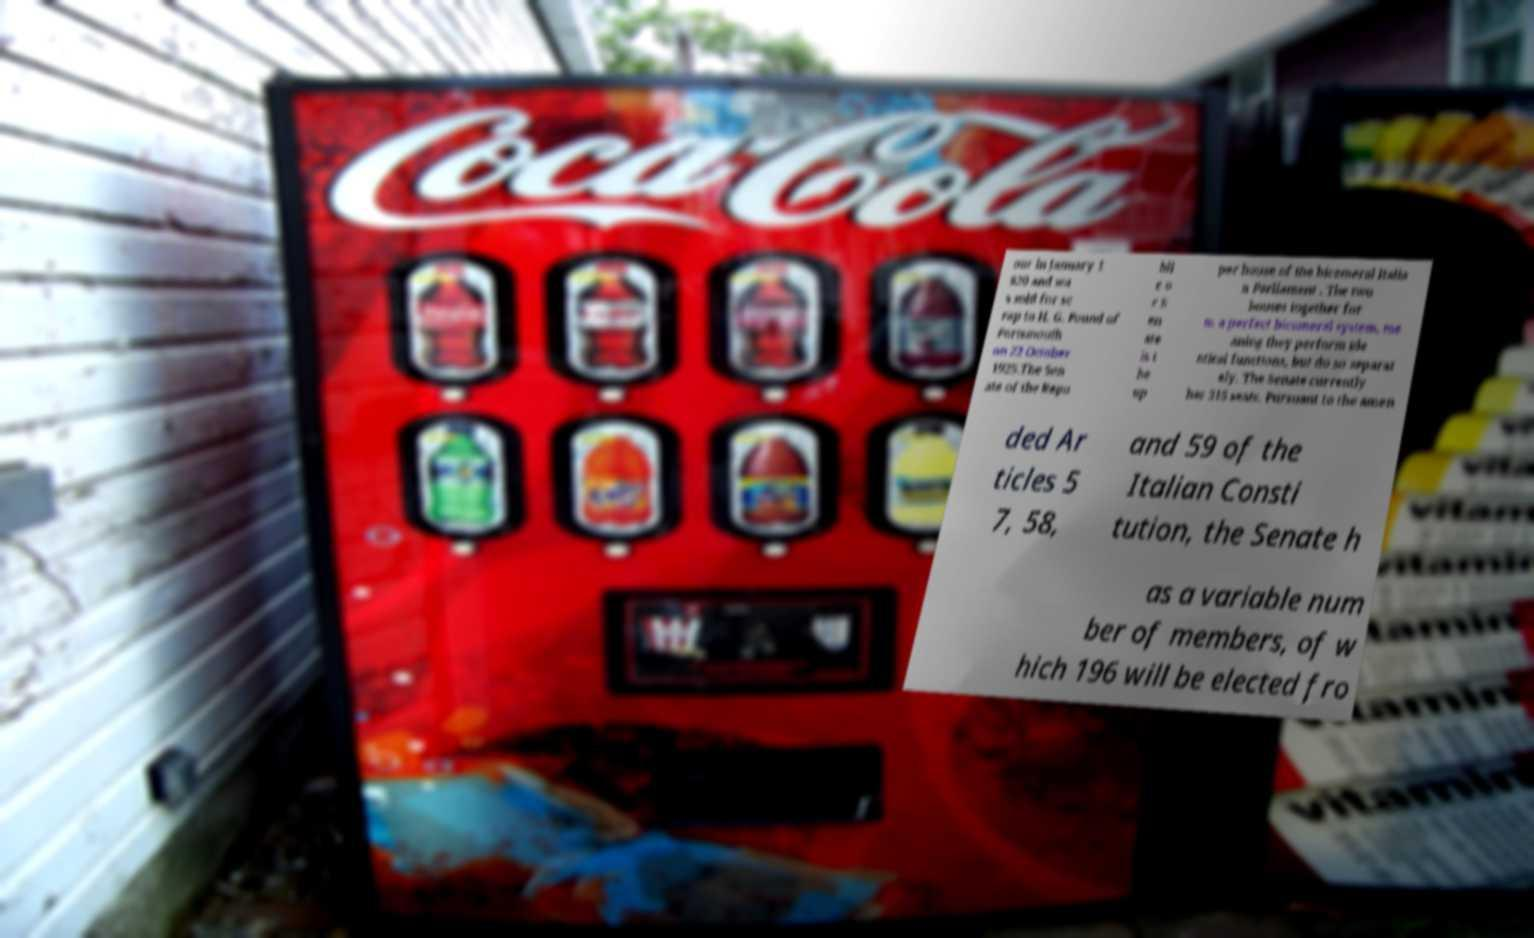Can you read and provide the text displayed in the image?This photo seems to have some interesting text. Can you extract and type it out for me? our in January 1 920 and wa s sold for sc rap to H. G. Pound of Portsmouth on 22 October 1925.The Sen ate of the Repu bli c o r S en ate is t he up per house of the bicameral Italia n Parliament . The two houses together for m a perfect bicameral system, me aning they perform ide ntical functions, but do so separat ely. The Senate currently has 315 seats. Pursuant to the amen ded Ar ticles 5 7, 58, and 59 of the Italian Consti tution, the Senate h as a variable num ber of members, of w hich 196 will be elected fro 